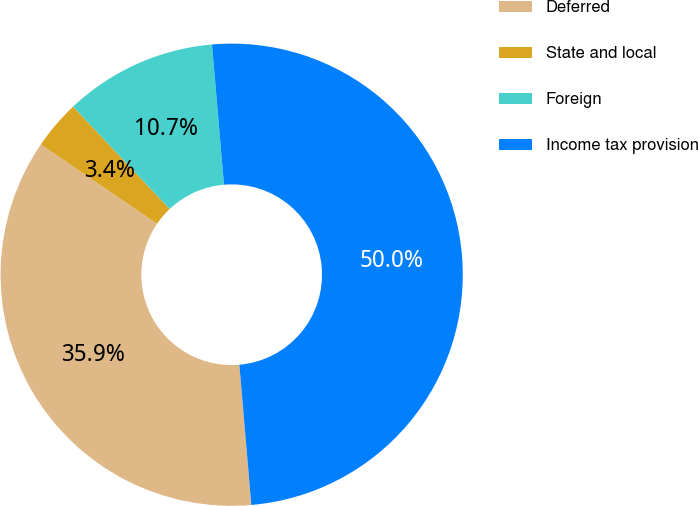<chart> <loc_0><loc_0><loc_500><loc_500><pie_chart><fcel>Deferred<fcel>State and local<fcel>Foreign<fcel>Income tax provision<nl><fcel>35.89%<fcel>3.43%<fcel>10.68%<fcel>50.0%<nl></chart> 